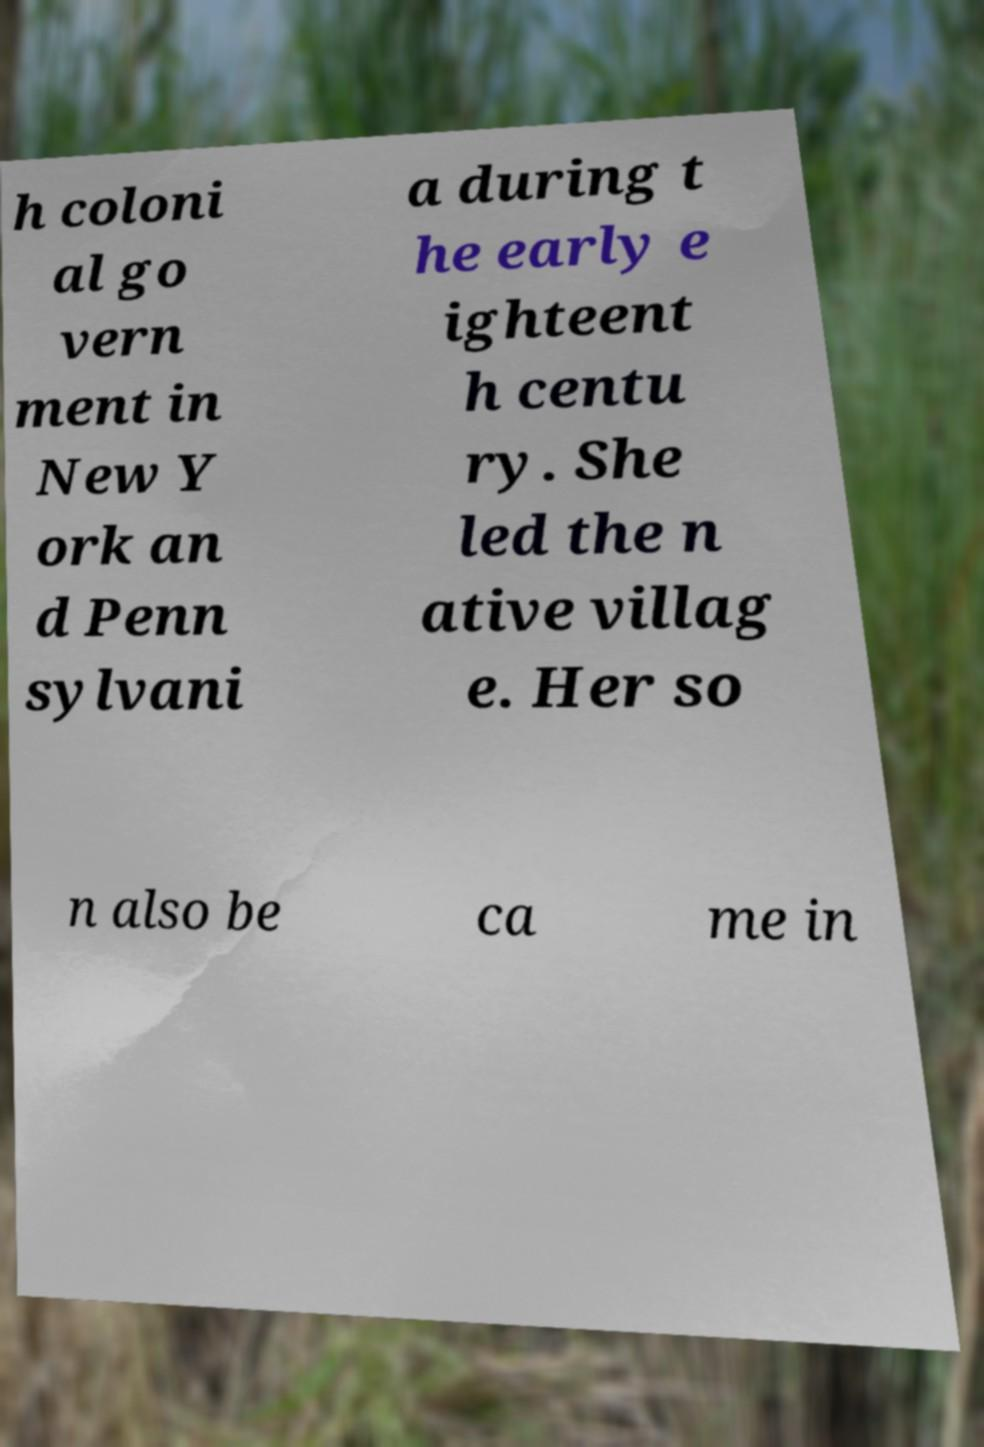Please read and relay the text visible in this image. What does it say? h coloni al go vern ment in New Y ork an d Penn sylvani a during t he early e ighteent h centu ry. She led the n ative villag e. Her so n also be ca me in 